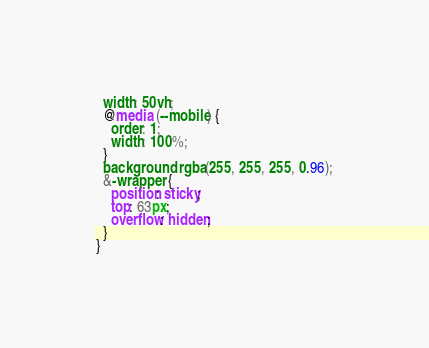<code> <loc_0><loc_0><loc_500><loc_500><_CSS_>  width: 50vh;
  @media (--mobile) {
    order: 1;
    width: 100%;
  }
  background: rgba(255, 255, 255, 0.96);
  &-wrapper {
    position: sticky;
    top: 63px;
    overflow: hidden;
  }
}
</code> 